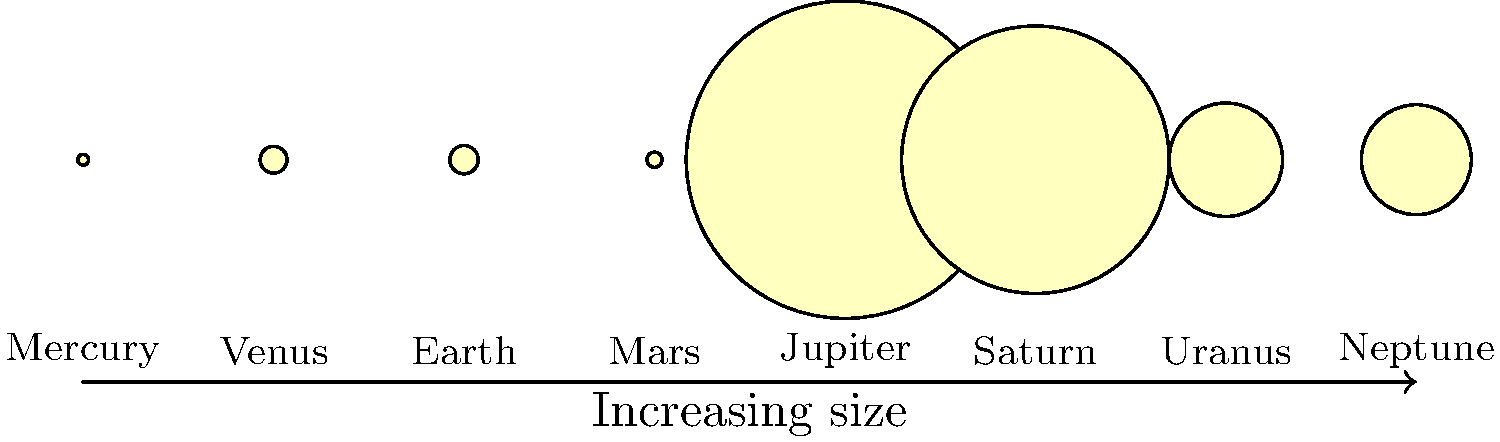Mon ami, imagine we're celebrating Bastille Day with a grand astronomical display! In this scale diagram of our solar system's planets, which celestial body would be the perfect representation of our beloved France's might and grandeur? Let's approach this question with the passion of a true French sports fan, analyzing our solar system as if it were our national football team:

1. We see all eight planets represented in the diagram, arranged from smallest to largest.

2. The sizes are scaled relative to each other, with Jupiter being the largest.

3. To find the planet that best represents France's might and grandeur, we should look for one that stands out but isn't overpowering – much like our balanced and skilled national team.

4. Mercury, Venus, Earth, and Mars are relatively small, like our agile midfielders.

5. Uranus and Neptune are larger, but not the largest, like our solid defenders.

6. Jupiter is the largest, which might be too dominating for our taste – we appreciate teamwork over individual stars.

7. Saturn, however, stands out as the second-largest planet. It's impressive without overshadowing the others, much like our striker who works harmoniously with the team.

8. Moreover, Saturn is known for its beautiful rings, which we can liken to the elegant style of French football.

Therefore, Saturn would be the perfect representation of France's might and grandeur in this cosmic lineup!
Answer: Saturn 